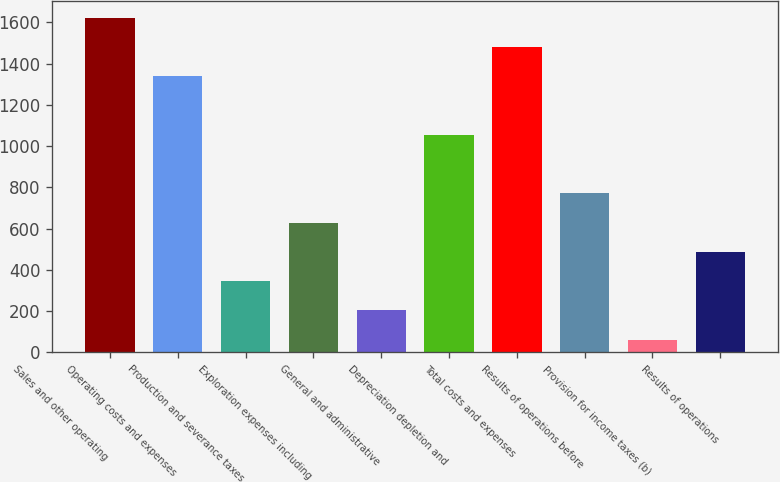Convert chart. <chart><loc_0><loc_0><loc_500><loc_500><bar_chart><fcel>Sales and other operating<fcel>Operating costs and expenses<fcel>Production and severance taxes<fcel>Exploration expenses including<fcel>General and administrative<fcel>Depreciation depletion and<fcel>Total costs and expenses<fcel>Results of operations before<fcel>Provision for income taxes (b)<fcel>Results of operations<nl><fcel>1624.2<fcel>1339.8<fcel>344.4<fcel>628.8<fcel>202.2<fcel>1055.4<fcel>1482<fcel>771<fcel>60<fcel>486.6<nl></chart> 